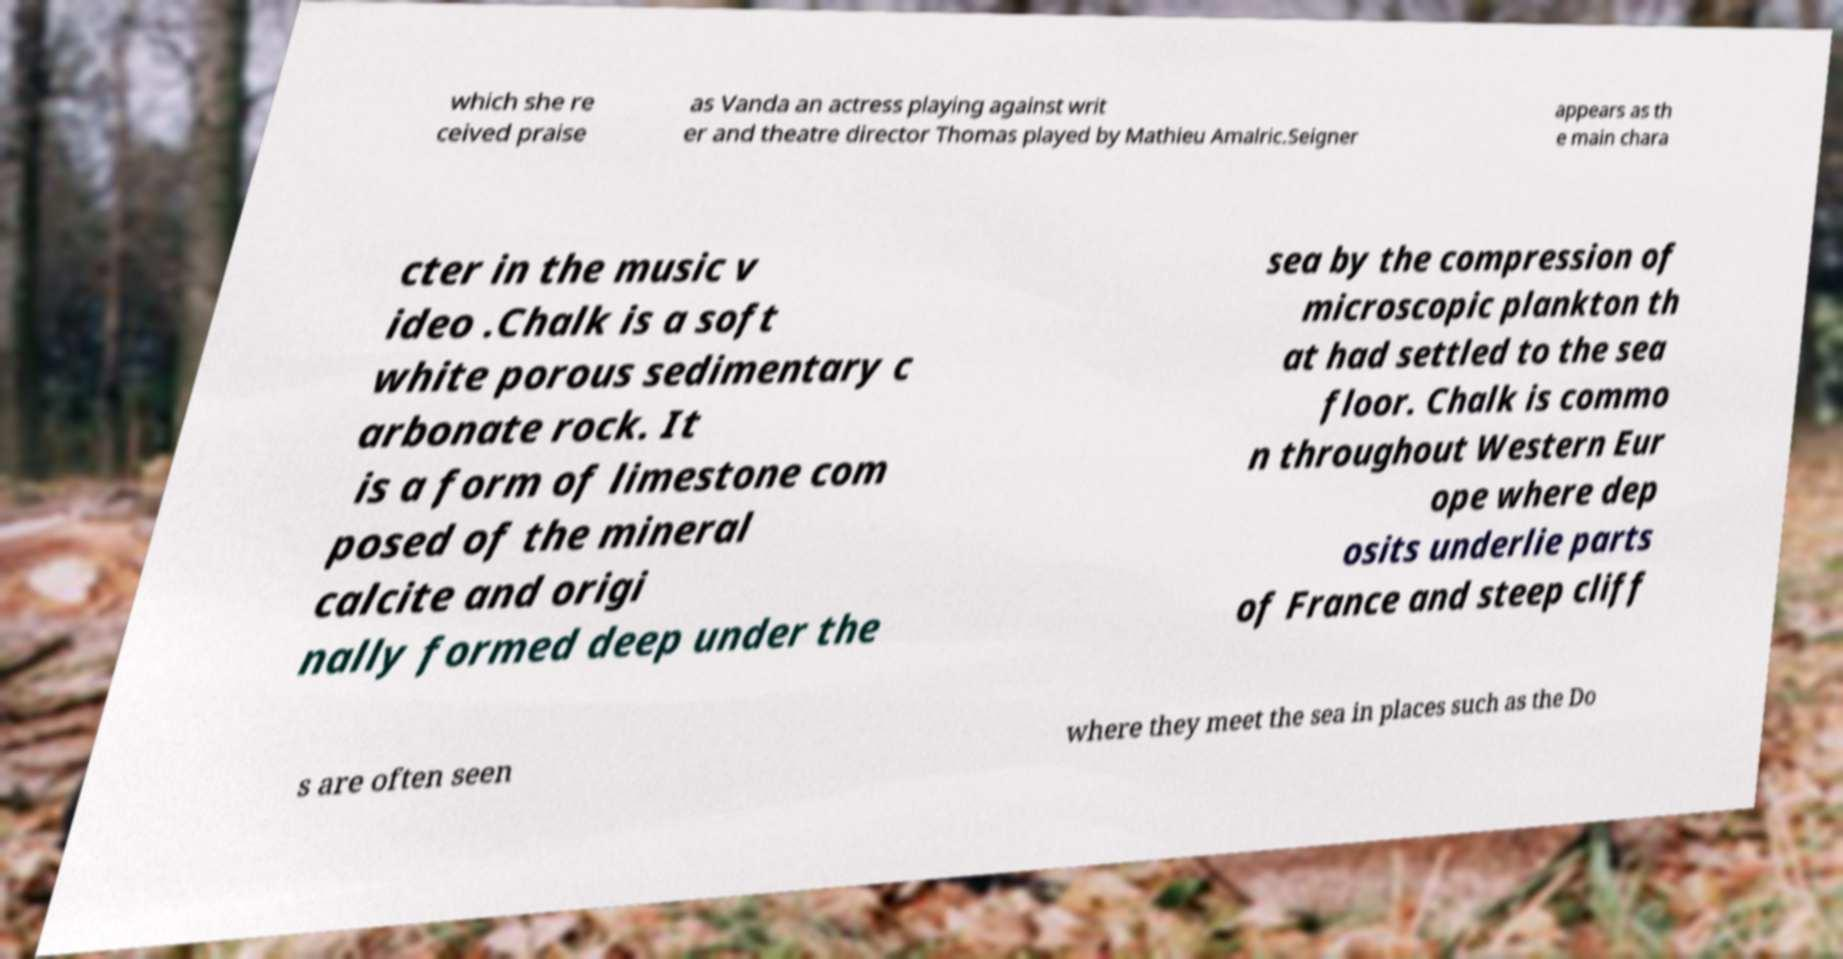Can you read and provide the text displayed in the image?This photo seems to have some interesting text. Can you extract and type it out for me? which she re ceived praise as Vanda an actress playing against writ er and theatre director Thomas played by Mathieu Amalric.Seigner appears as th e main chara cter in the music v ideo .Chalk is a soft white porous sedimentary c arbonate rock. It is a form of limestone com posed of the mineral calcite and origi nally formed deep under the sea by the compression of microscopic plankton th at had settled to the sea floor. Chalk is commo n throughout Western Eur ope where dep osits underlie parts of France and steep cliff s are often seen where they meet the sea in places such as the Do 